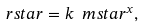<formula> <loc_0><loc_0><loc_500><loc_500>\ r s t a r = k \ m s t a r ^ { x } ,</formula> 